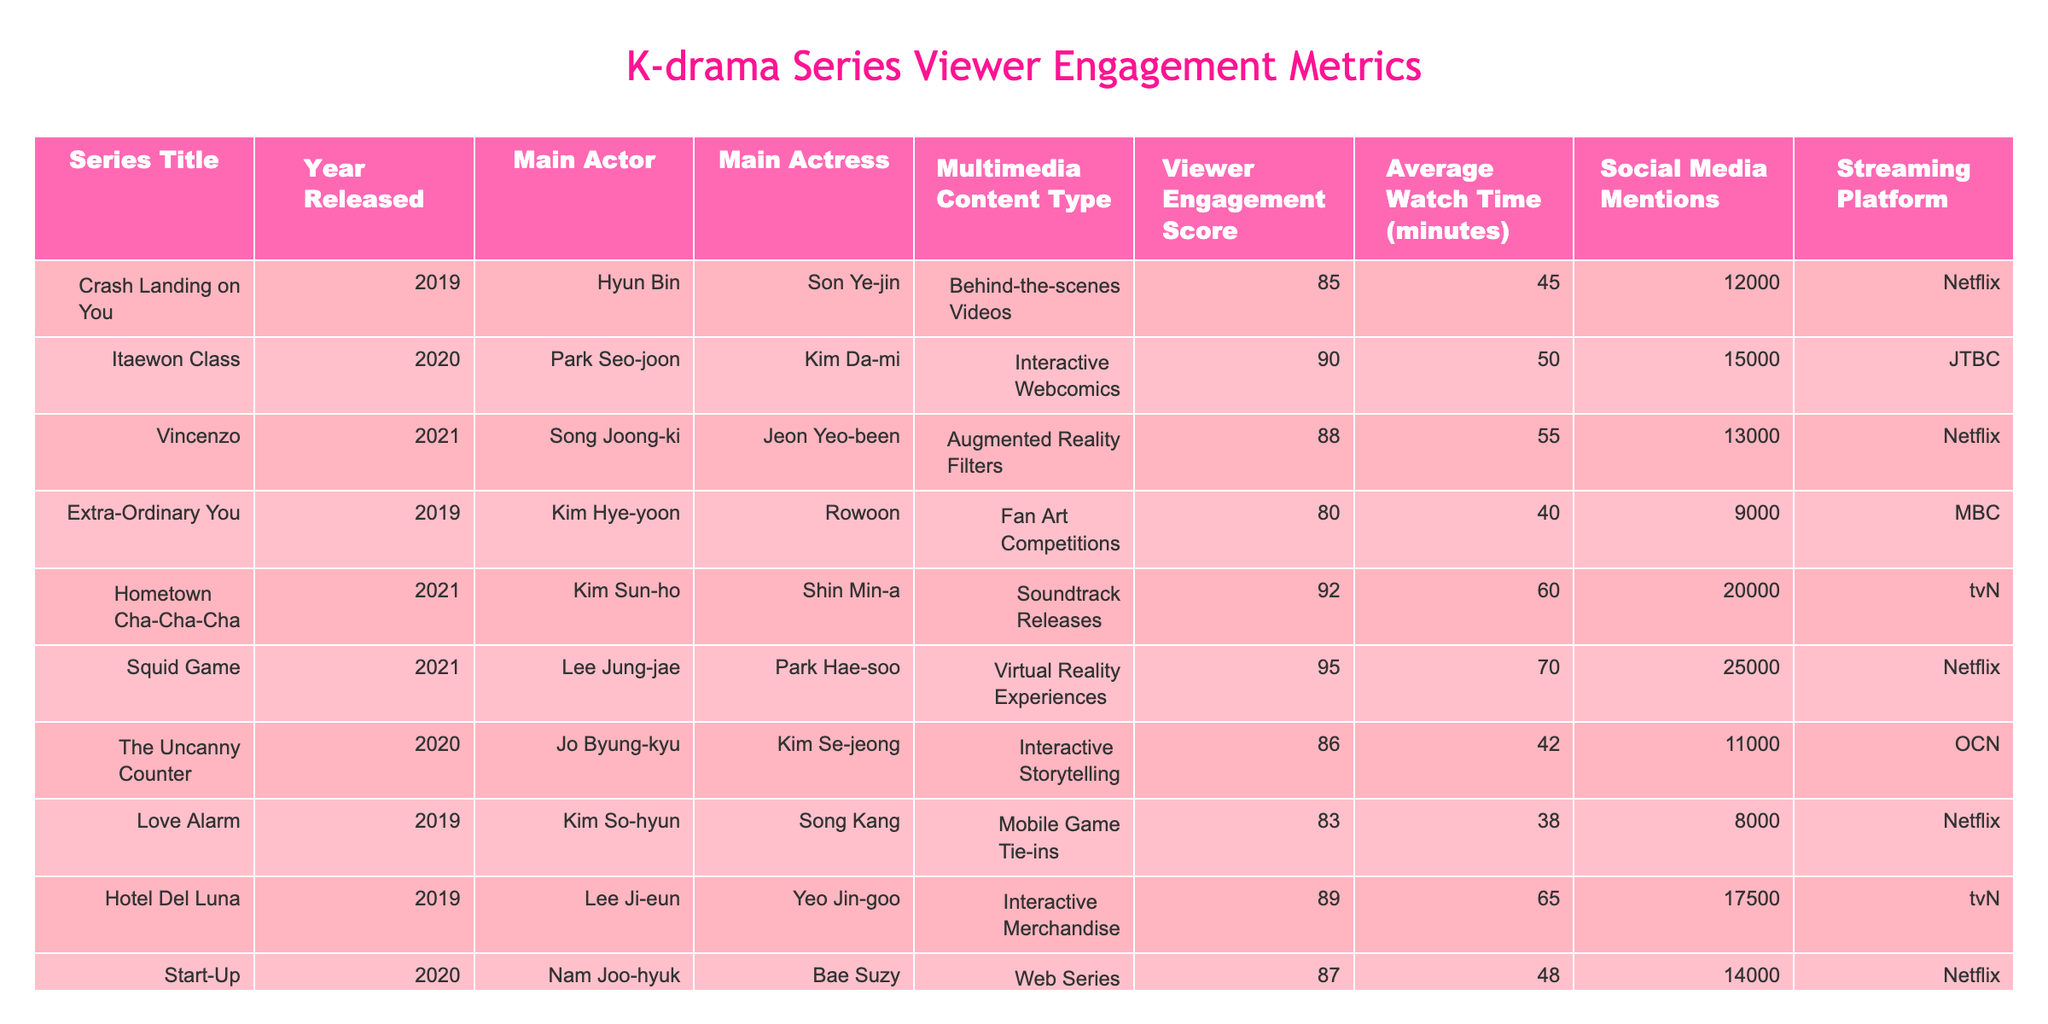What is the viewer engagement score for "Squid Game"? The viewer engagement score for "Squid Game" is listed in the table, corresponding to the series title. It shows a score of 95.
Answer: 95 Which series has the highest average watch time? The average watch time is provided for each series in the table. "Squid Game" has the highest average watch time of 70 minutes.
Answer: 70 minutes Did "Love Alarm" have interactive content? According to the table, "Love Alarm" featured mobile game tie-ins, which is a form of interactive content.
Answer: Yes What is the total number of social media mentions for the series released in 2020? Summing the social media mentions for all 2020 series: "Itaewon Class" (15000) + "The Uncanny Counter" (11000) + "Start-Up" (14000) gives a total of 40000 mentions.
Answer: 40000 Which series, starring a main actress, has the lowest viewer engagement score? The viewer engagement scores for series featuring actresses can be compared: "Love Alarm" (83), "Hotel Del Luna" (89), "Hometown Cha-Cha-Cha" (92), and "Extra-Ordinary You" (80). "Extra-Ordinary You" has the lowest score.
Answer: "Extra-Ordinary You" What is the average viewer engagement score for series featuring interactive multimedia content? The series with interactive multimedia are "Itaewon Class" (90), "The Uncanny Counter" (86), "Extra-Ordinary You" (80), and "Love Alarm" (83). The average is calculated as (90 + 86 + 80 + 83) / 4 = 85.75.
Answer: 85.75 How many series have a viewer engagement score above 85? By checking the table, the series with scores above 85 are "Itaewon Class" (90), "Vincenzo" (88), "Hometown Cha-Cha-Cha" (92), "Squid Game" (95), and "Hotel Del Luna" (89), which totals 5 series.
Answer: 5 Which streaming platform has the most series featured in this table? By observing the table, "Netflix" has four series: "Crash Landing on You", "Vincenzo", "Squid Game", and "Love Alarm", more than any other platform.
Answer: Netflix What is the difference in average watch time between "Hometown Cha-Cha-Cha" and "Extra-Ordinary You"? The average watch time for "Hometown Cha-Cha-Cha" is 60 minutes, and for "Extra-Ordinary You", it is 40 minutes. The difference is 60 - 40 = 20 minutes.
Answer: 20 minutes Is there any series starring Hyun Bin with a social media mention count above 10000? Checking the table shows "Crash Landing on You" starring Hyun Bin has 12000 social media mentions, which is above 10000.
Answer: Yes What percentage of the total social media mentions does "Squid Game" contribute? The total social media mentions are 12000 (CLO) + 15000 (Itaewon Class) + 13000 (Vincenzo) + 9000 (EOY) + 20000 (Hometown Cha-Cha-Cha) + 25000 (Squid Game) + 11000 (TUC) + 8000 (Love Alarm) + 17500 (Hotel Del Luna) + 14000 (Start-Up) = 1,30000. "Squid Game" has 25000 mentions, thus, (25000 / 130000) * 100 = 19.23%.
Answer: 19.23% 